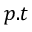<formula> <loc_0><loc_0><loc_500><loc_500>p . t</formula> 